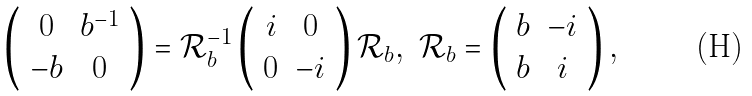Convert formula to latex. <formula><loc_0><loc_0><loc_500><loc_500>\left ( \begin{array} { c c } 0 & b ^ { - 1 } \\ - b & 0 \end{array} \right ) = \mathcal { R } _ { b } ^ { - 1 } \left ( \begin{array} { c c } i & 0 \\ 0 & - i \end{array} \right ) \mathcal { R } _ { b } , \ \mathcal { R } _ { b } = \left ( \begin{array} { c c } b & - i \\ b & i \end{array} \right ) ,</formula> 